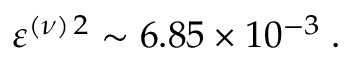<formula> <loc_0><loc_0><loc_500><loc_500>\varepsilon ^ { ( \nu ) \, 2 } \sim 6 . 8 5 \times 1 0 ^ { - 3 } \, .</formula> 